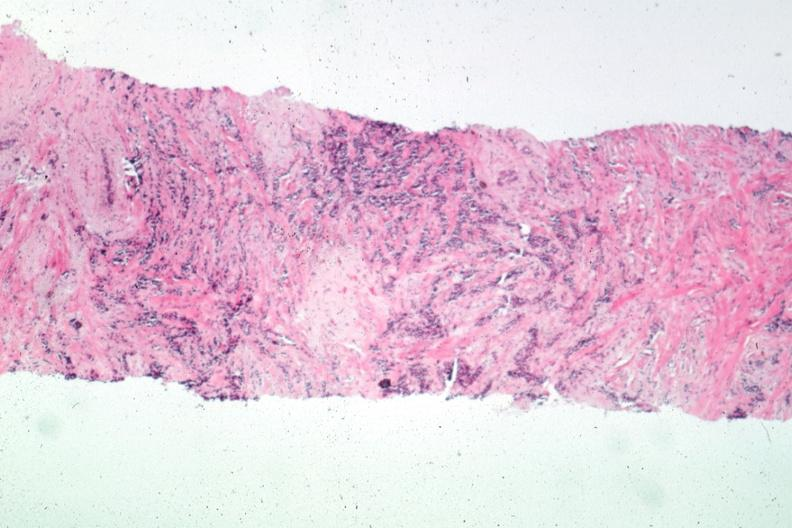s breast present?
Answer the question using a single word or phrase. Yes 